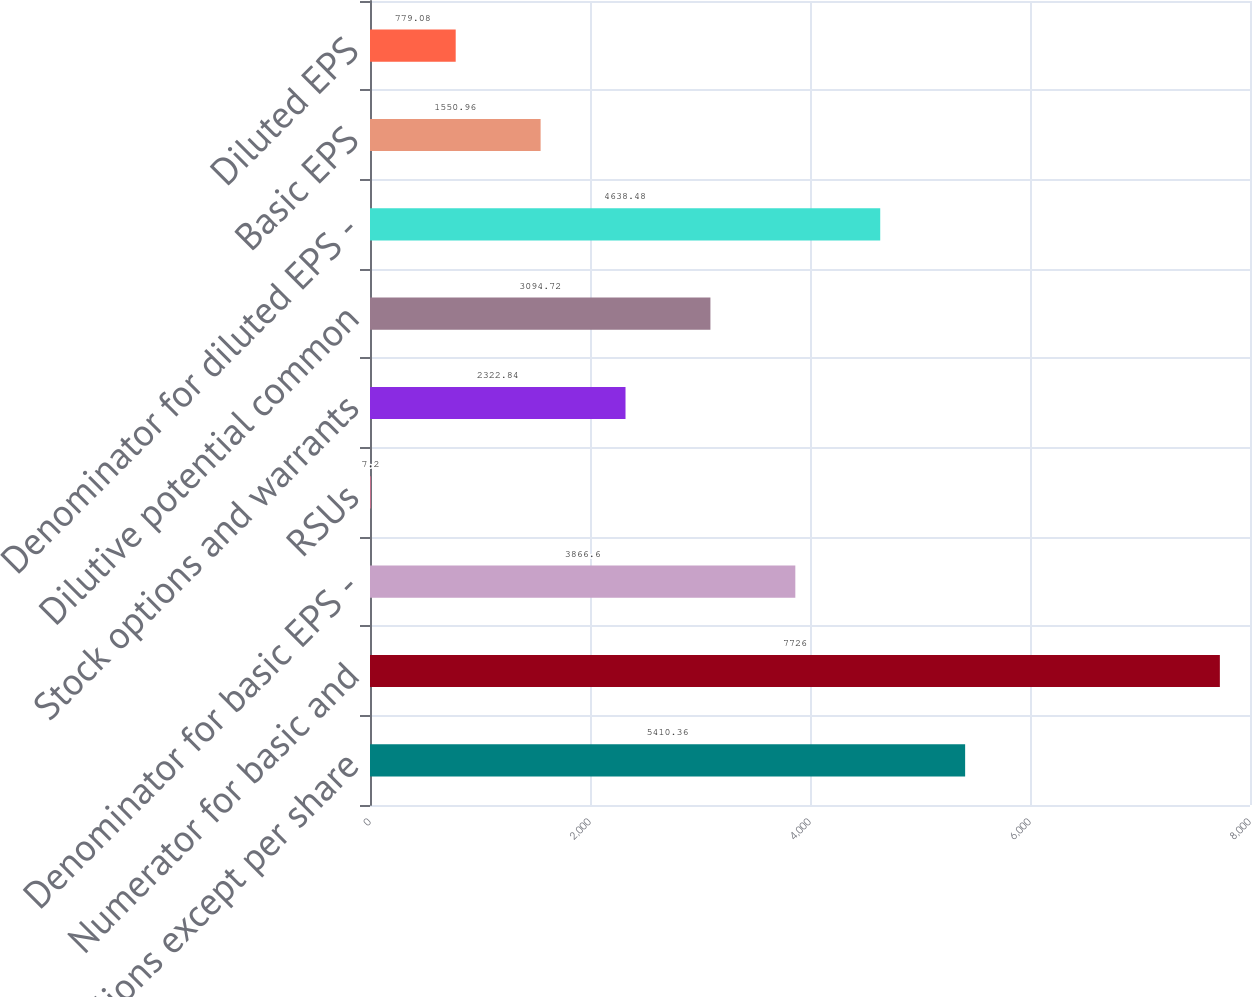Convert chart to OTSL. <chart><loc_0><loc_0><loc_500><loc_500><bar_chart><fcel>in millions except per share<fcel>Numerator for basic and<fcel>Denominator for basic EPS -<fcel>RSUs<fcel>Stock options and warrants<fcel>Dilutive potential common<fcel>Denominator for diluted EPS -<fcel>Basic EPS<fcel>Diluted EPS<nl><fcel>5410.36<fcel>7726<fcel>3866.6<fcel>7.2<fcel>2322.84<fcel>3094.72<fcel>4638.48<fcel>1550.96<fcel>779.08<nl></chart> 